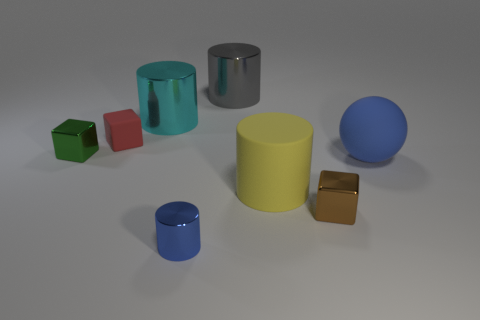Is the color of the metallic cylinder that is in front of the large cyan metal thing the same as the thing that is right of the brown thing?
Offer a very short reply. Yes. Is there a tiny cylinder that has the same color as the sphere?
Your answer should be compact. Yes. There is a object that is the same color as the rubber ball; what is it made of?
Provide a short and direct response. Metal. What number of things are brown metallic cubes or tiny red rubber blocks?
Make the answer very short. 2. What size is the metallic cylinder in front of the matte block?
Your response must be concise. Small. How many blue objects are right of the small metallic object that is in front of the block that is on the right side of the yellow matte thing?
Provide a short and direct response. 1. Is the color of the small shiny cylinder the same as the big rubber sphere?
Ensure brevity in your answer.  Yes. How many metallic cylinders are both in front of the tiny brown shiny block and behind the small green shiny cube?
Keep it short and to the point. 0. There is a large object right of the tiny brown metal block; what is its shape?
Give a very brief answer. Sphere. Are there fewer metallic objects that are right of the blue ball than red matte objects in front of the small cylinder?
Make the answer very short. No. 